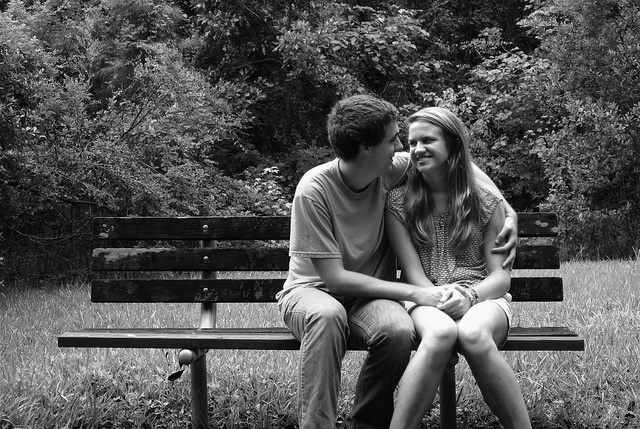Describe the objects in this image and their specific colors. I can see bench in black, darkgray, gray, and lightgray tones, people in black, gray, darkgray, and lightgray tones, and people in black, gray, darkgray, and lightgray tones in this image. 